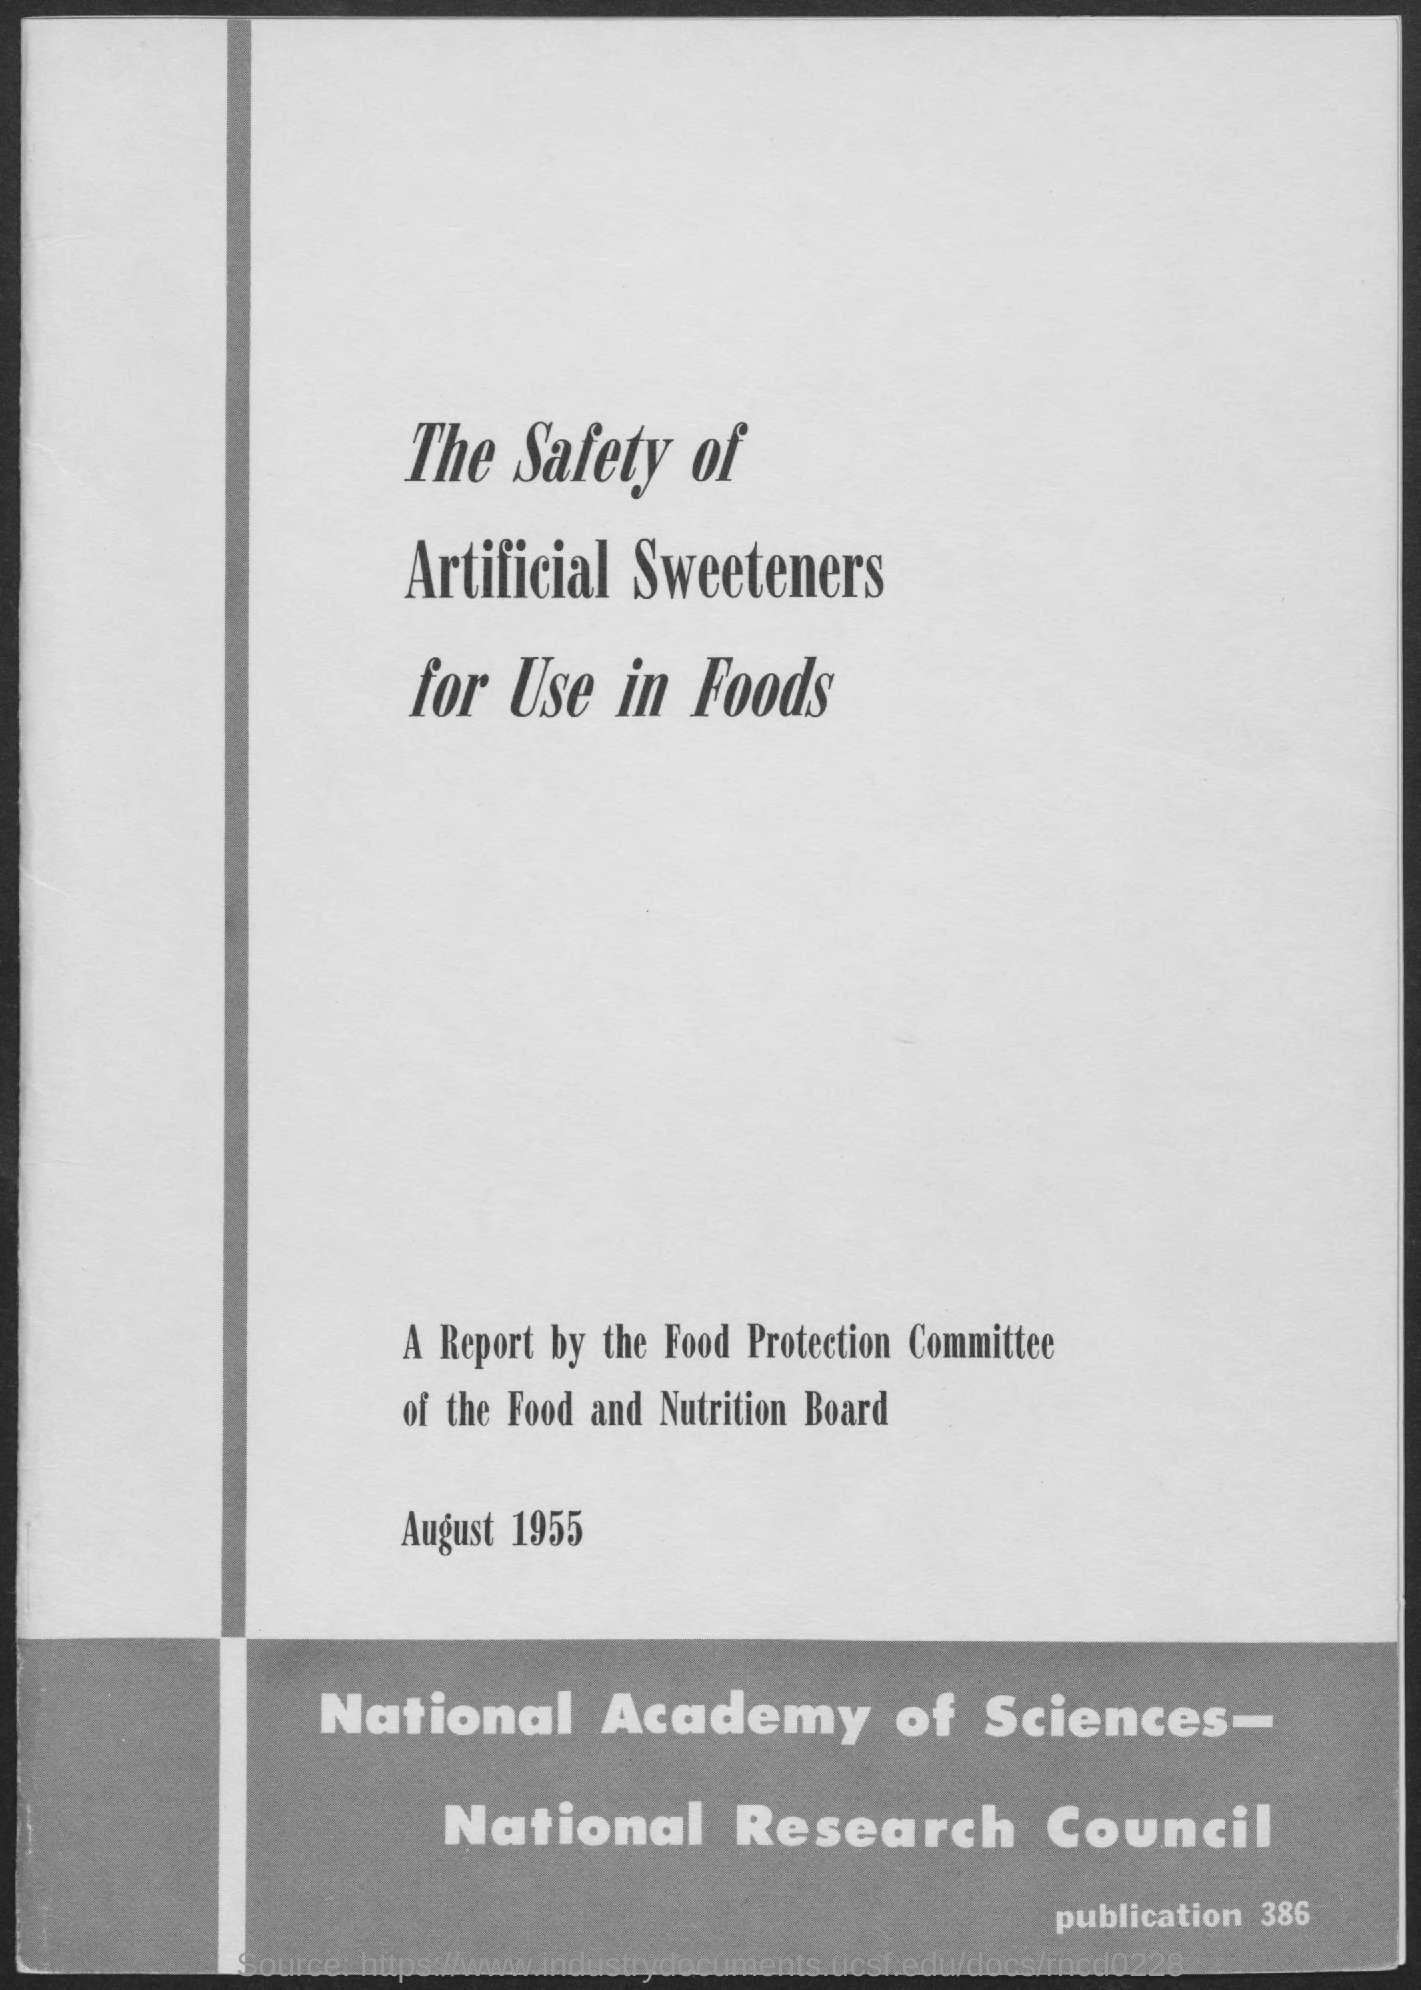What is the date on the document?
Give a very brief answer. August 1955. What is the publication Number?
Your answer should be compact. Publication 386. 